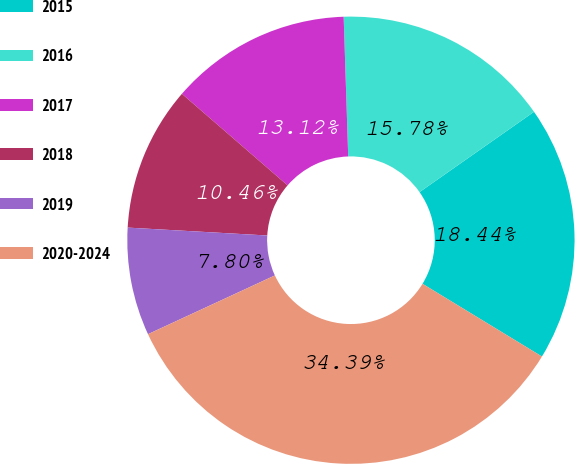Convert chart to OTSL. <chart><loc_0><loc_0><loc_500><loc_500><pie_chart><fcel>2015<fcel>2016<fcel>2017<fcel>2018<fcel>2019<fcel>2020-2024<nl><fcel>18.44%<fcel>15.78%<fcel>13.12%<fcel>10.46%<fcel>7.8%<fcel>34.39%<nl></chart> 